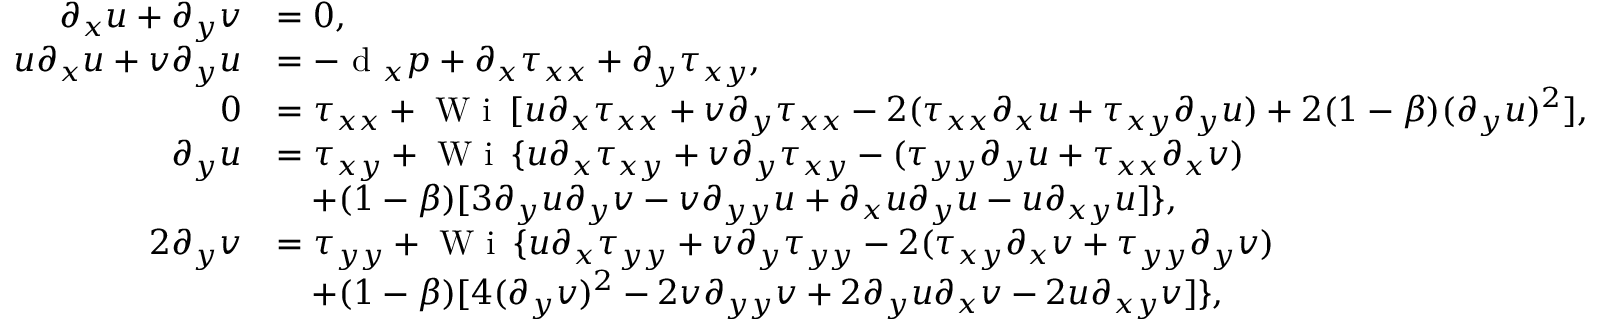<formula> <loc_0><loc_0><loc_500><loc_500>\begin{array} { r l } { \partial _ { x } u + \partial _ { y } v } & { = 0 , } \\ { u \partial _ { x } u + v \partial _ { y } u } & { = - d _ { x } p + \partial _ { x } \tau _ { x x } + \partial _ { y } \tau _ { x y } , } \\ { 0 } & { = \tau _ { x x } + W i \, [ u \partial _ { x } \tau _ { x x } + v \partial _ { y } \tau _ { x x } - 2 ( \tau _ { x x } \partial _ { x } u + \tau _ { x y } \partial _ { y } u ) + 2 ( 1 - \beta ) ( \partial _ { y } u ) ^ { 2 } ] , } \\ { \partial _ { y } u } & { = \tau _ { x y } + W i \, \{ u \partial _ { x } \tau _ { x y } + v \partial _ { y } \tau _ { x y } - ( \tau _ { y y } \partial _ { y } u + \tau _ { x x } \partial _ { x } v ) } \\ & { \quad + ( 1 - \beta ) [ 3 \partial _ { y } u \partial _ { y } v - v \partial _ { y y } u + \partial _ { x } u \partial _ { y } u - u \partial _ { x y } u ] \} , } \\ { 2 \partial _ { y } v } & { = \tau _ { y y } + W i \, \{ u \partial _ { x } \tau _ { y y } + v \partial _ { y } \tau _ { y y } - 2 ( \tau _ { x y } \partial _ { x } v + \tau _ { y y } \partial _ { y } v ) } \\ & { \quad + ( 1 - \beta ) [ 4 ( \partial _ { y } v ) ^ { 2 } - 2 v \partial _ { y y } v + 2 \partial _ { y } u \partial _ { x } v - 2 u \partial _ { x y } v ] \} , } \end{array}</formula> 